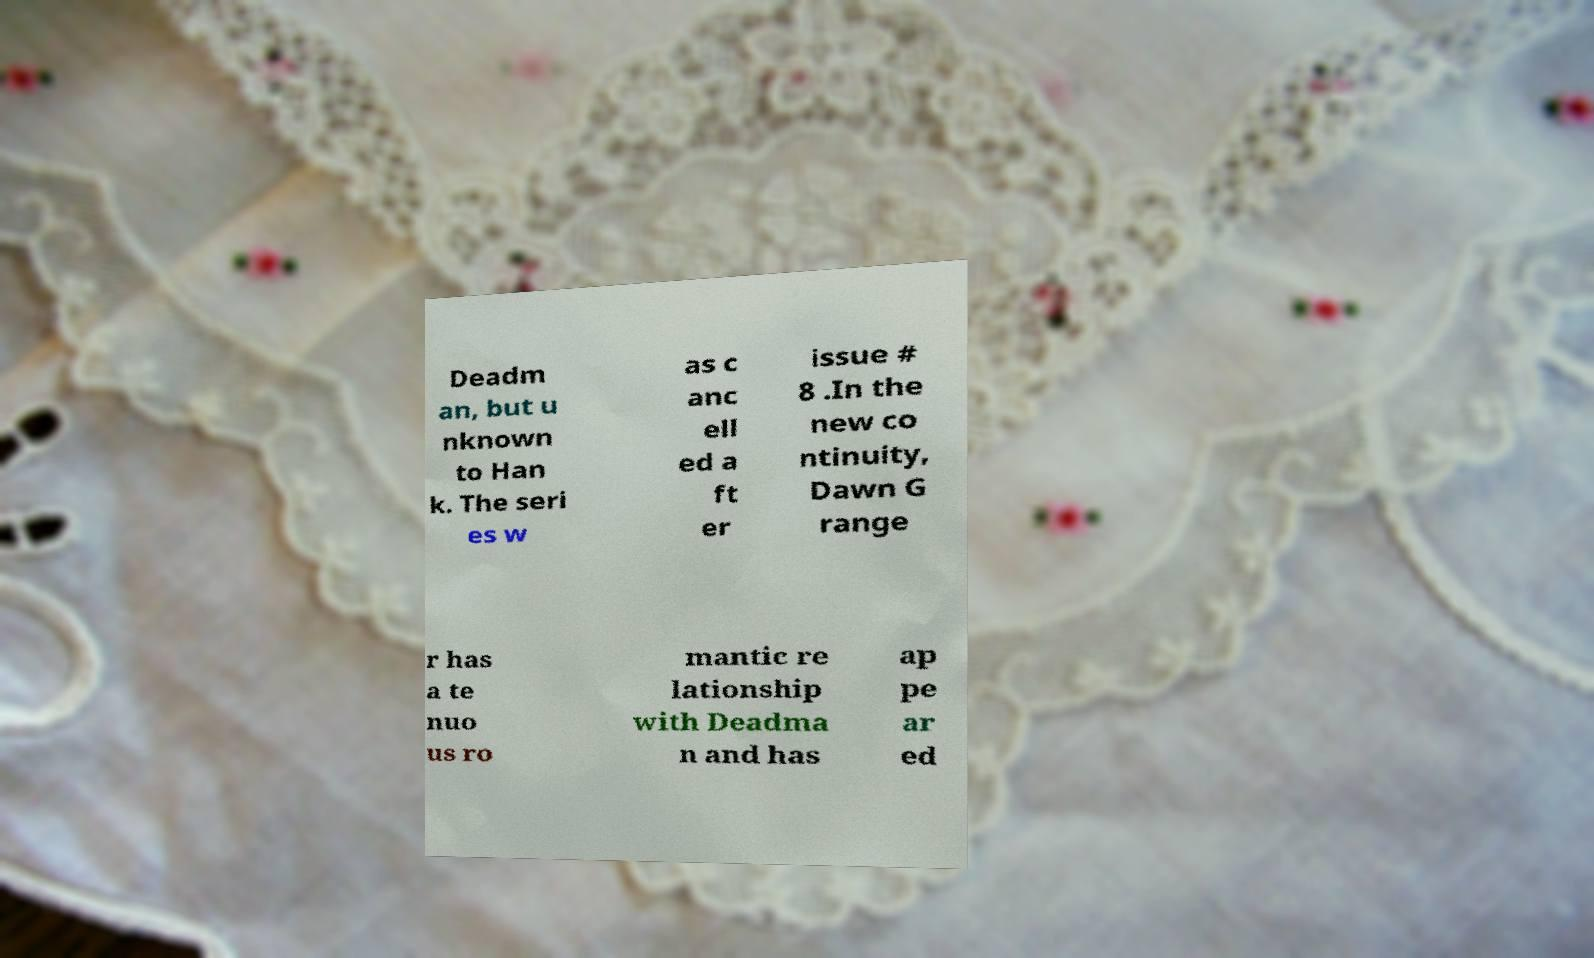What messages or text are displayed in this image? I need them in a readable, typed format. Deadm an, but u nknown to Han k. The seri es w as c anc ell ed a ft er issue # 8 .In the new co ntinuity, Dawn G range r has a te nuo us ro mantic re lationship with Deadma n and has ap pe ar ed 